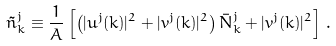Convert formula to latex. <formula><loc_0><loc_0><loc_500><loc_500>\tilde { n } ^ { j } _ { k } \equiv \frac { 1 } { A } \left [ \left ( | u ^ { j } ( { k } ) | ^ { 2 } + | v ^ { j } ( { k } ) | ^ { 2 } \right ) \bar { N } ^ { j } _ { k } + | v ^ { j } ( { k } ) | ^ { 2 } \right ] \, .</formula> 